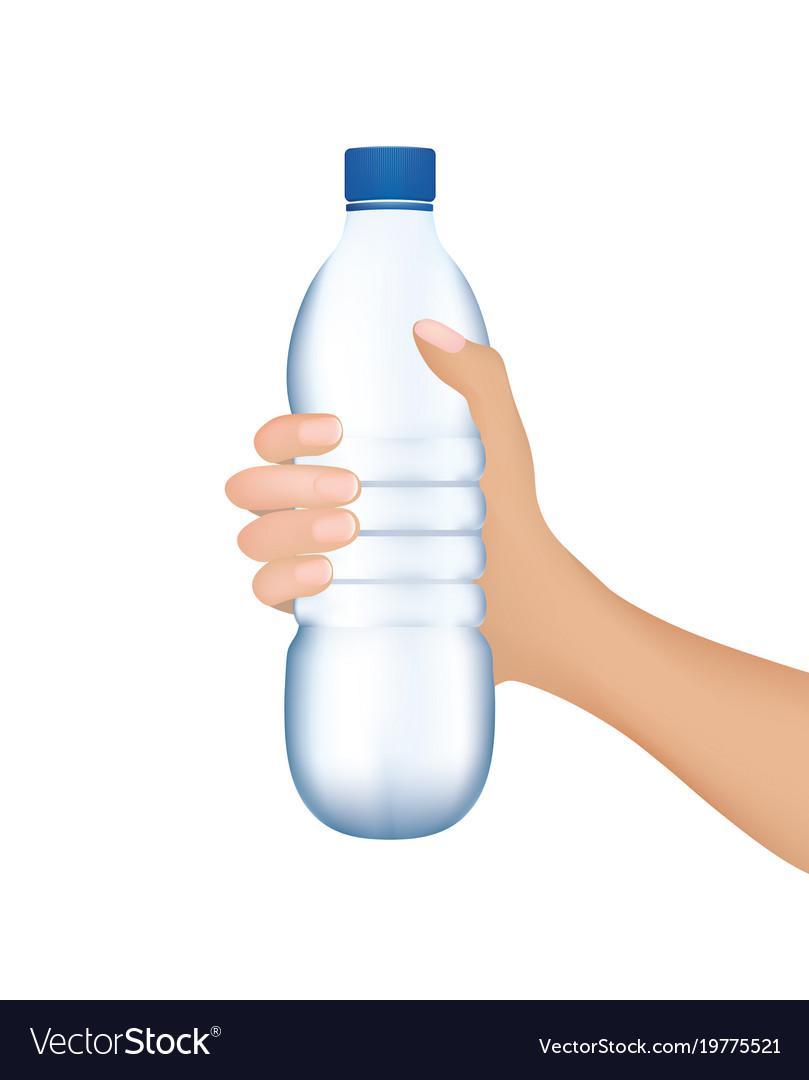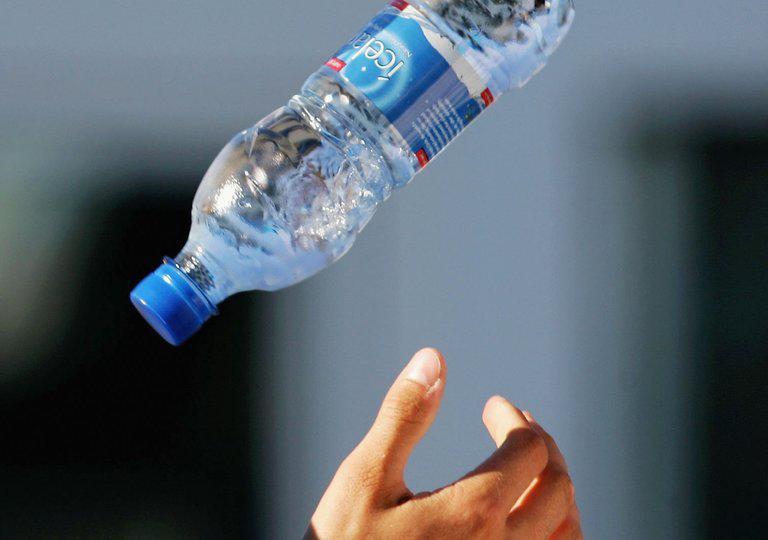The first image is the image on the left, the second image is the image on the right. Considering the images on both sides, is "Each image shows exactly one hand holding one water bottle." valid? Answer yes or no. No. 